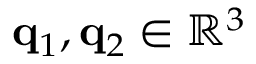<formula> <loc_0><loc_0><loc_500><loc_500>q _ { 1 } , q _ { 2 } \in \mathbb { R } ^ { 3 }</formula> 